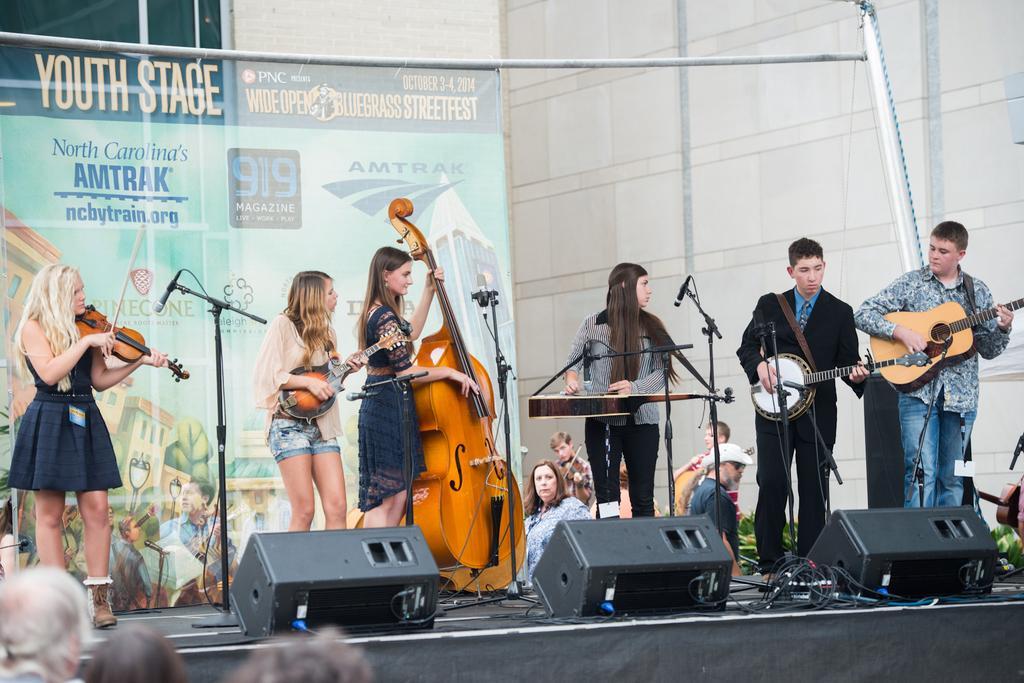Describe this image in one or two sentences. In this picture we can see some group of people playing musical instruments such as violin, guitar and in front of them there are mice, wires , lights and in background we can see banner,wall, some more persons. 